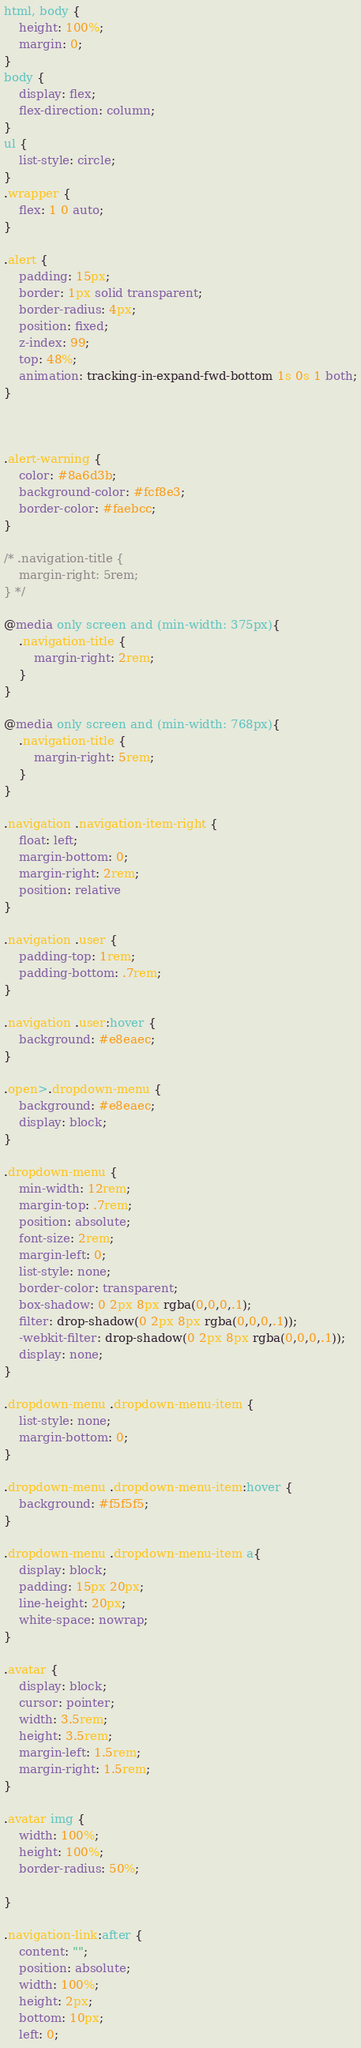Convert code to text. <code><loc_0><loc_0><loc_500><loc_500><_CSS_>html, body {
    height: 100%;
    margin: 0;
}
body {
    display: flex;
    flex-direction: column;
}
ul {
    list-style: circle;
}
.wrapper {
    flex: 1 0 auto;
}

.alert {
    padding: 15px;
    border: 1px solid transparent;
    border-radius: 4px;
    position: fixed;
    z-index: 99;
    top: 48%;
    animation: tracking-in-expand-fwd-bottom 1s 0s 1 both;
}



.alert-warning {
    color: #8a6d3b;
    background-color: #fcf8e3;
    border-color: #faebcc;
}

/* .navigation-title {
    margin-right: 5rem;
} */

@media only screen and (min-width: 375px){
    .navigation-title {
        margin-right: 2rem;
    }
}

@media only screen and (min-width: 768px){
    .navigation-title {
        margin-right: 5rem;
    }
}

.navigation .navigation-item-right {
    float: left;
    margin-bottom: 0;
    margin-right: 2rem;
    position: relative
}

.navigation .user {
    padding-top: 1rem;
    padding-bottom: .7rem;
}

.navigation .user:hover {
    background: #e8eaec;
}

.open>.dropdown-menu {
    background: #e8eaec;
    display: block;
}

.dropdown-menu {
    min-width: 12rem;
    margin-top: .7rem;
    position: absolute;
    font-size: 2rem;
    margin-left: 0;
    list-style: none;
    border-color: transparent;
    box-shadow: 0 2px 8px rgba(0,0,0,.1);
    filter: drop-shadow(0 2px 8px rgba(0,0,0,.1));
    -webkit-filter: drop-shadow(0 2px 8px rgba(0,0,0,.1));
    display: none;
}

.dropdown-menu .dropdown-menu-item {
    list-style: none;
    margin-bottom: 0;
}

.dropdown-menu .dropdown-menu-item:hover {
    background: #f5f5f5;
}

.dropdown-menu .dropdown-menu-item a{
    display: block;
    padding: 15px 20px;
    line-height: 20px;
    white-space: nowrap;
}

.avatar {
    display: block;
    cursor: pointer;
    width: 3.5rem;
    height: 3.5rem;
    margin-left: 1.5rem;
    margin-right: 1.5rem;
}

.avatar img {
    width: 100%;
    height: 100%;
    border-radius: 50%;

}

.navigation-link:after {
    content: "";
    position: absolute;
    width: 100%;
    height: 2px;
    bottom: 10px;
    left: 0;</code> 